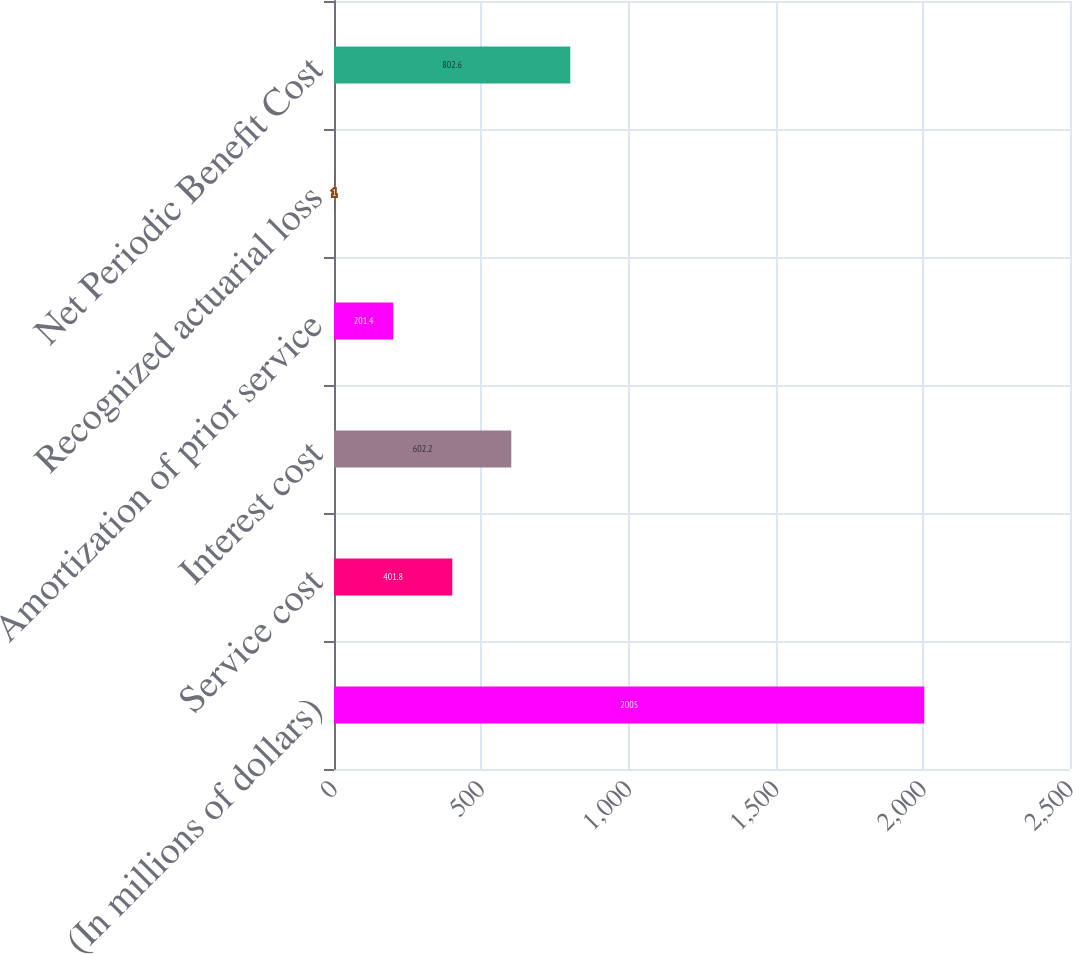<chart> <loc_0><loc_0><loc_500><loc_500><bar_chart><fcel>(In millions of dollars)<fcel>Service cost<fcel>Interest cost<fcel>Amortization of prior service<fcel>Recognized actuarial loss<fcel>Net Periodic Benefit Cost<nl><fcel>2005<fcel>401.8<fcel>602.2<fcel>201.4<fcel>1<fcel>802.6<nl></chart> 